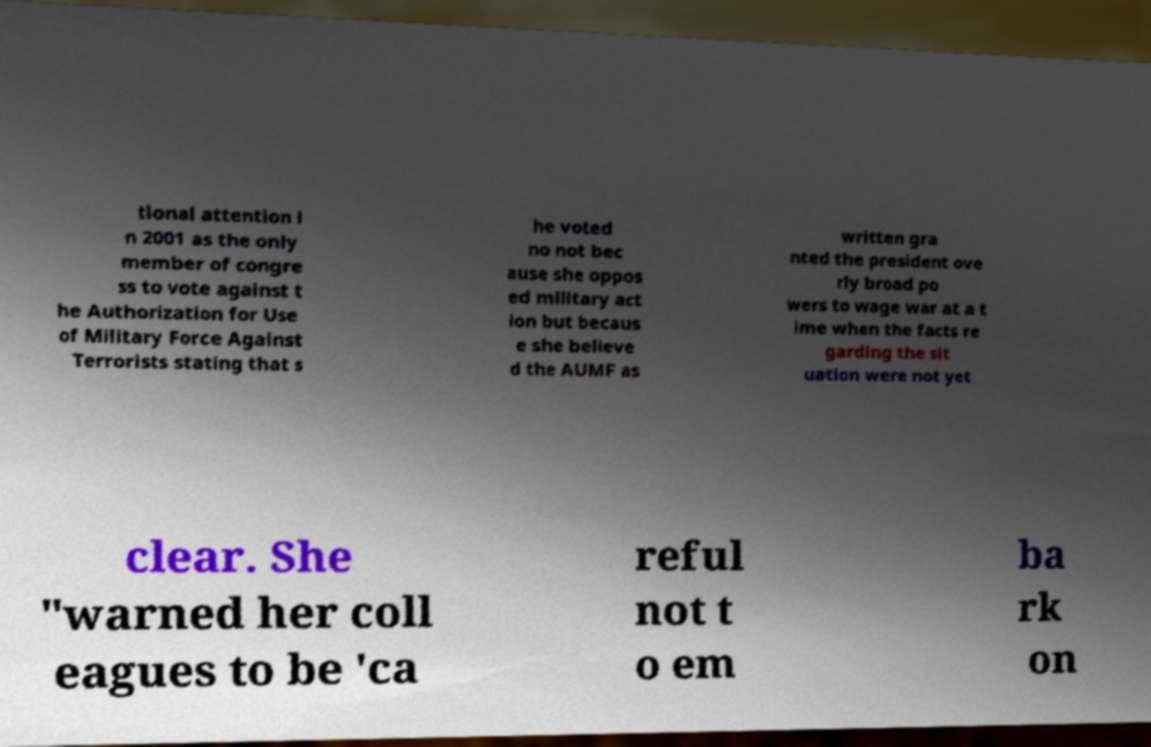What messages or text are displayed in this image? I need them in a readable, typed format. tional attention i n 2001 as the only member of congre ss to vote against t he Authorization for Use of Military Force Against Terrorists stating that s he voted no not bec ause she oppos ed military act ion but becaus e she believe d the AUMF as written gra nted the president ove rly broad po wers to wage war at a t ime when the facts re garding the sit uation were not yet clear. She "warned her coll eagues to be 'ca reful not t o em ba rk on 